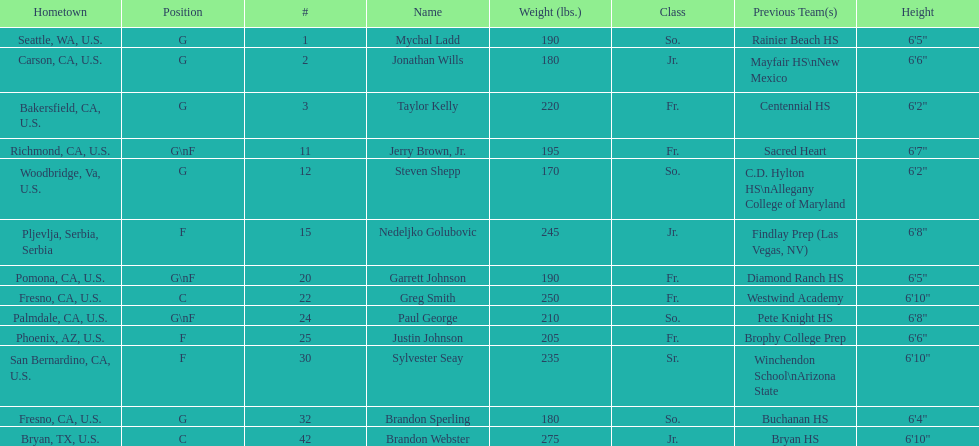Can you parse all the data within this table? {'header': ['Hometown', 'Position', '#', 'Name', 'Weight (lbs.)', 'Class', 'Previous Team(s)', 'Height'], 'rows': [['Seattle, WA, U.S.', 'G', '1', 'Mychal Ladd', '190', 'So.', 'Rainier Beach HS', '6\'5"'], ['Carson, CA, U.S.', 'G', '2', 'Jonathan Wills', '180', 'Jr.', 'Mayfair HS\\nNew Mexico', '6\'6"'], ['Bakersfield, CA, U.S.', 'G', '3', 'Taylor Kelly', '220', 'Fr.', 'Centennial HS', '6\'2"'], ['Richmond, CA, U.S.', 'G\\nF', '11', 'Jerry Brown, Jr.', '195', 'Fr.', 'Sacred Heart', '6\'7"'], ['Woodbridge, Va, U.S.', 'G', '12', 'Steven Shepp', '170', 'So.', 'C.D. Hylton HS\\nAllegany College of Maryland', '6\'2"'], ['Pljevlja, Serbia, Serbia', 'F', '15', 'Nedeljko Golubovic', '245', 'Jr.', 'Findlay Prep (Las Vegas, NV)', '6\'8"'], ['Pomona, CA, U.S.', 'G\\nF', '20', 'Garrett Johnson', '190', 'Fr.', 'Diamond Ranch HS', '6\'5"'], ['Fresno, CA, U.S.', 'C', '22', 'Greg Smith', '250', 'Fr.', 'Westwind Academy', '6\'10"'], ['Palmdale, CA, U.S.', 'G\\nF', '24', 'Paul George', '210', 'So.', 'Pete Knight HS', '6\'8"'], ['Phoenix, AZ, U.S.', 'F', '25', 'Justin Johnson', '205', 'Fr.', 'Brophy College Prep', '6\'6"'], ['San Bernardino, CA, U.S.', 'F', '30', 'Sylvester Seay', '235', 'Sr.', 'Winchendon School\\nArizona State', '6\'10"'], ['Fresno, CA, U.S.', 'G', '32', 'Brandon Sperling', '180', 'So.', 'Buchanan HS', '6\'4"'], ['Bryan, TX, U.S.', 'C', '42', 'Brandon Webster', '275', 'Jr.', 'Bryan HS', '6\'10"']]} Is the number of freshmen (fr.) greater than, equal to, or less than the number of juniors (jr.)? Greater. 